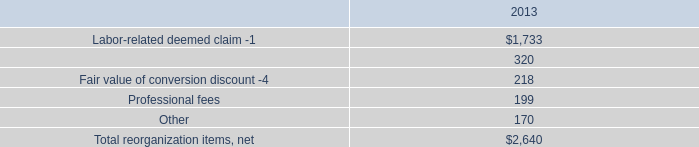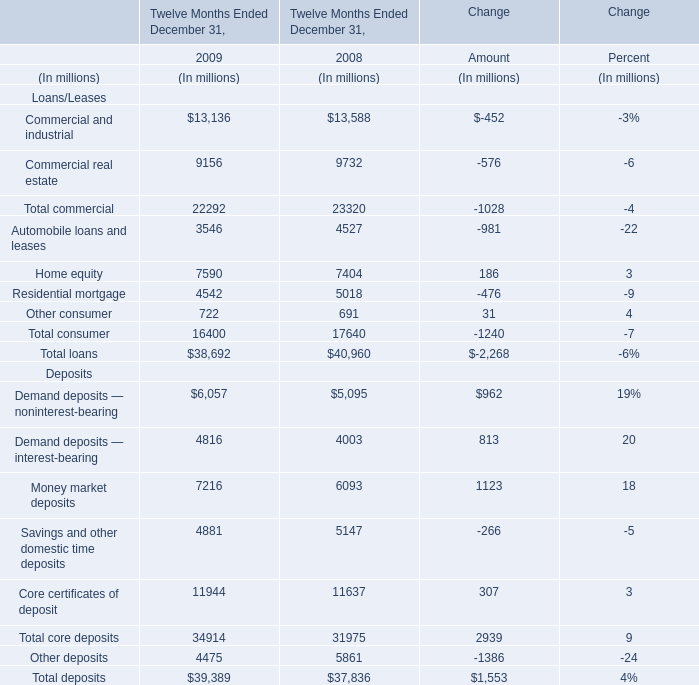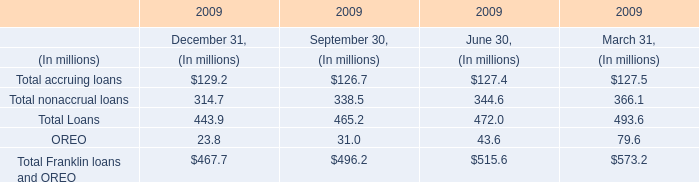What's the total amount of the Other consumer in the years where Commercial real estate greater than 0? (in million) 
Computations: (722 + 691)
Answer: 1413.0. 